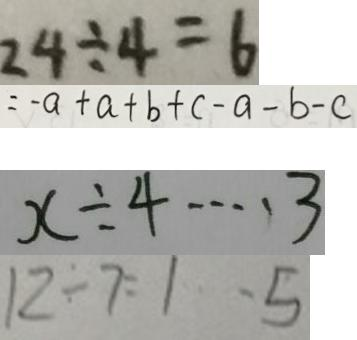<formula> <loc_0><loc_0><loc_500><loc_500>2 4 \div 4 = 6 
 = - a + a + b + c - a - b - c 
 x \div 4 \cdots 3 
 1 2 \div 7 = 1 \cdots 5</formula> 